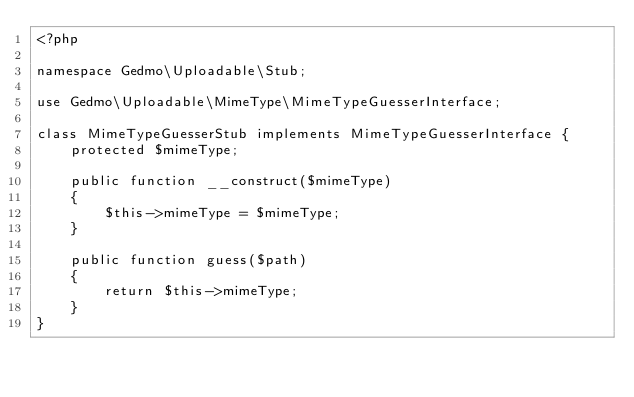Convert code to text. <code><loc_0><loc_0><loc_500><loc_500><_PHP_><?php

namespace Gedmo\Uploadable\Stub;

use Gedmo\Uploadable\MimeType\MimeTypeGuesserInterface;

class MimeTypeGuesserStub implements MimeTypeGuesserInterface {
    protected $mimeType;

    public function __construct($mimeType)
    {
        $this->mimeType = $mimeType;
    }

    public function guess($path)
    {
        return $this->mimeType;
    }
}
</code> 